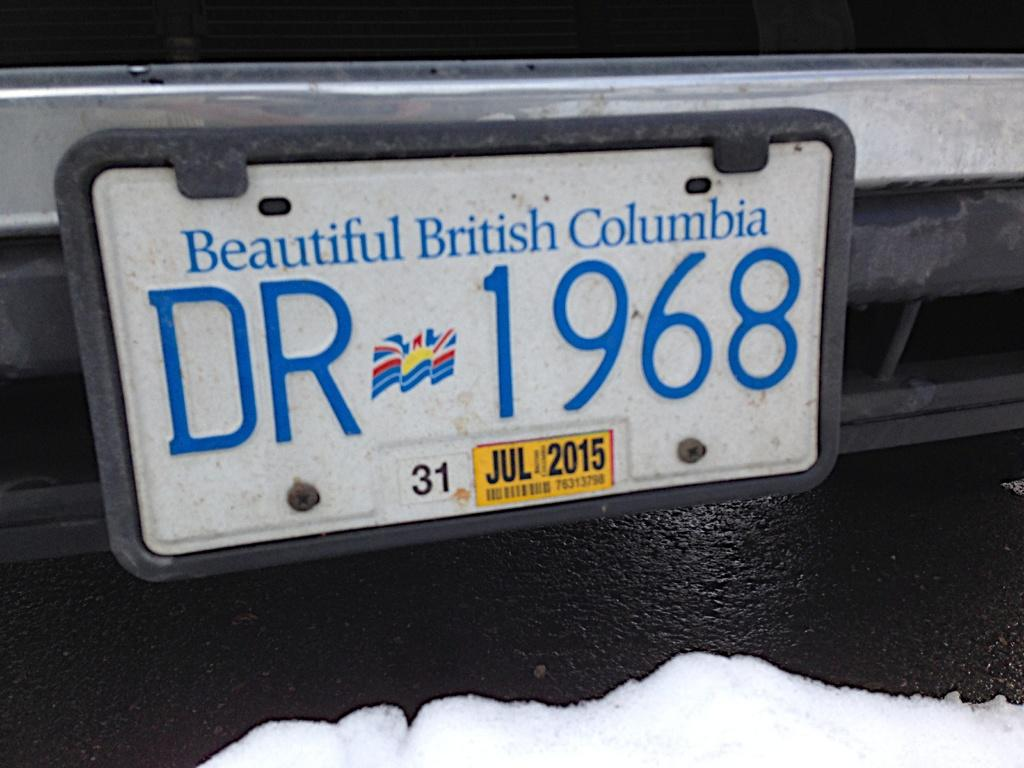<image>
Create a compact narrative representing the image presented. A license plate from British Columbia says DR 1968. 